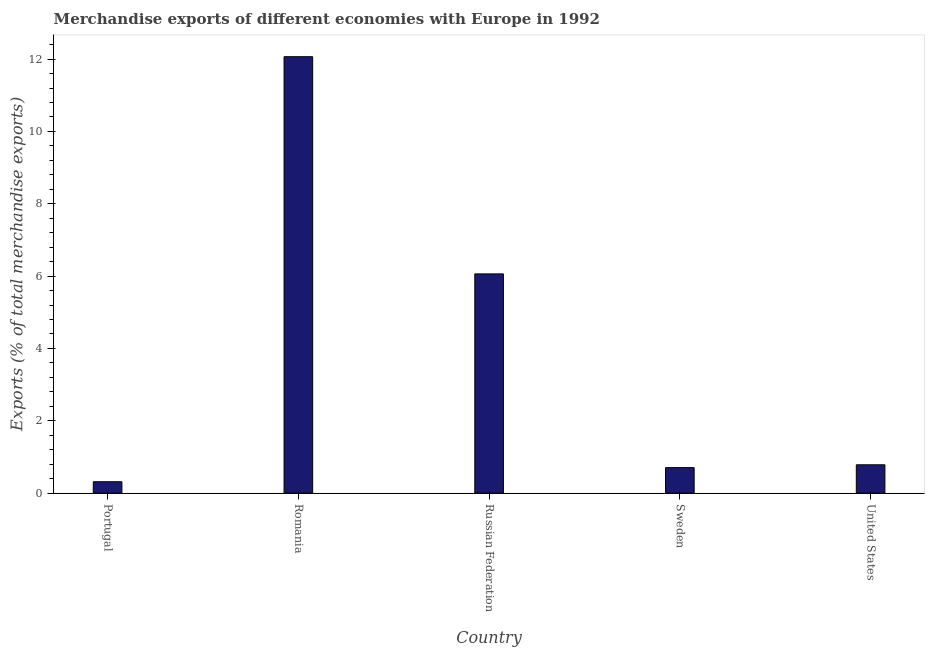Does the graph contain grids?
Give a very brief answer. No. What is the title of the graph?
Provide a succinct answer. Merchandise exports of different economies with Europe in 1992. What is the label or title of the X-axis?
Provide a succinct answer. Country. What is the label or title of the Y-axis?
Provide a succinct answer. Exports (% of total merchandise exports). What is the merchandise exports in United States?
Your answer should be compact. 0.78. Across all countries, what is the maximum merchandise exports?
Make the answer very short. 12.07. Across all countries, what is the minimum merchandise exports?
Keep it short and to the point. 0.32. In which country was the merchandise exports maximum?
Your answer should be very brief. Romania. In which country was the merchandise exports minimum?
Keep it short and to the point. Portugal. What is the sum of the merchandise exports?
Your answer should be compact. 19.93. What is the difference between the merchandise exports in Romania and Russian Federation?
Offer a very short reply. 6. What is the average merchandise exports per country?
Provide a short and direct response. 3.99. What is the median merchandise exports?
Provide a succinct answer. 0.78. In how many countries, is the merchandise exports greater than 6 %?
Give a very brief answer. 2. What is the ratio of the merchandise exports in Portugal to that in Russian Federation?
Offer a terse response. 0.05. Is the merchandise exports in Portugal less than that in Russian Federation?
Your answer should be compact. Yes. Is the difference between the merchandise exports in Portugal and United States greater than the difference between any two countries?
Make the answer very short. No. What is the difference between the highest and the second highest merchandise exports?
Provide a short and direct response. 6. What is the difference between the highest and the lowest merchandise exports?
Your answer should be compact. 11.75. How many bars are there?
Give a very brief answer. 5. Are all the bars in the graph horizontal?
Offer a terse response. No. How many countries are there in the graph?
Your answer should be compact. 5. What is the Exports (% of total merchandise exports) of Portugal?
Keep it short and to the point. 0.32. What is the Exports (% of total merchandise exports) in Romania?
Provide a short and direct response. 12.07. What is the Exports (% of total merchandise exports) in Russian Federation?
Offer a terse response. 6.06. What is the Exports (% of total merchandise exports) in Sweden?
Keep it short and to the point. 0.71. What is the Exports (% of total merchandise exports) in United States?
Offer a terse response. 0.78. What is the difference between the Exports (% of total merchandise exports) in Portugal and Romania?
Provide a succinct answer. -11.75. What is the difference between the Exports (% of total merchandise exports) in Portugal and Russian Federation?
Keep it short and to the point. -5.75. What is the difference between the Exports (% of total merchandise exports) in Portugal and Sweden?
Your answer should be compact. -0.39. What is the difference between the Exports (% of total merchandise exports) in Portugal and United States?
Keep it short and to the point. -0.47. What is the difference between the Exports (% of total merchandise exports) in Romania and Russian Federation?
Give a very brief answer. 6. What is the difference between the Exports (% of total merchandise exports) in Romania and Sweden?
Provide a succinct answer. 11.36. What is the difference between the Exports (% of total merchandise exports) in Romania and United States?
Your response must be concise. 11.28. What is the difference between the Exports (% of total merchandise exports) in Russian Federation and Sweden?
Ensure brevity in your answer.  5.36. What is the difference between the Exports (% of total merchandise exports) in Russian Federation and United States?
Offer a very short reply. 5.28. What is the difference between the Exports (% of total merchandise exports) in Sweden and United States?
Your answer should be compact. -0.08. What is the ratio of the Exports (% of total merchandise exports) in Portugal to that in Romania?
Ensure brevity in your answer.  0.03. What is the ratio of the Exports (% of total merchandise exports) in Portugal to that in Russian Federation?
Offer a very short reply. 0.05. What is the ratio of the Exports (% of total merchandise exports) in Portugal to that in Sweden?
Ensure brevity in your answer.  0.45. What is the ratio of the Exports (% of total merchandise exports) in Portugal to that in United States?
Ensure brevity in your answer.  0.4. What is the ratio of the Exports (% of total merchandise exports) in Romania to that in Russian Federation?
Offer a terse response. 1.99. What is the ratio of the Exports (% of total merchandise exports) in Romania to that in Sweden?
Your response must be concise. 17.09. What is the ratio of the Exports (% of total merchandise exports) in Romania to that in United States?
Your answer should be very brief. 15.39. What is the ratio of the Exports (% of total merchandise exports) in Russian Federation to that in Sweden?
Your answer should be very brief. 8.59. What is the ratio of the Exports (% of total merchandise exports) in Russian Federation to that in United States?
Your answer should be compact. 7.73. 